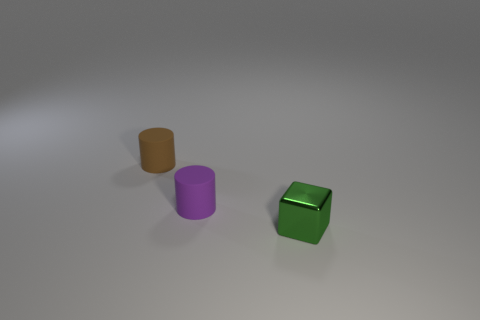There is a green shiny object; are there any small brown rubber cylinders in front of it? no 